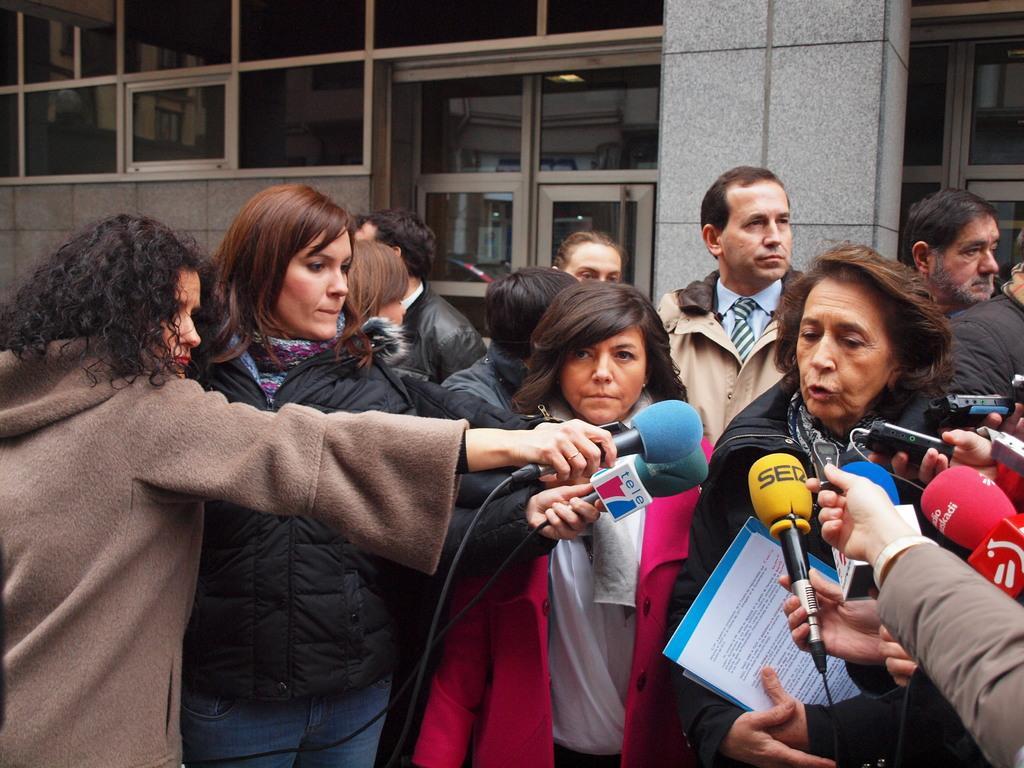Describe this image in one or two sentences. In this image there are many people and on the right there is a woman she is talking , i think there are many press people here. On the left there are two women there are holding mics, they are staring at woman. In the middle there is a woman they are staring at woman. In the background there are many people, building,window and glass. 